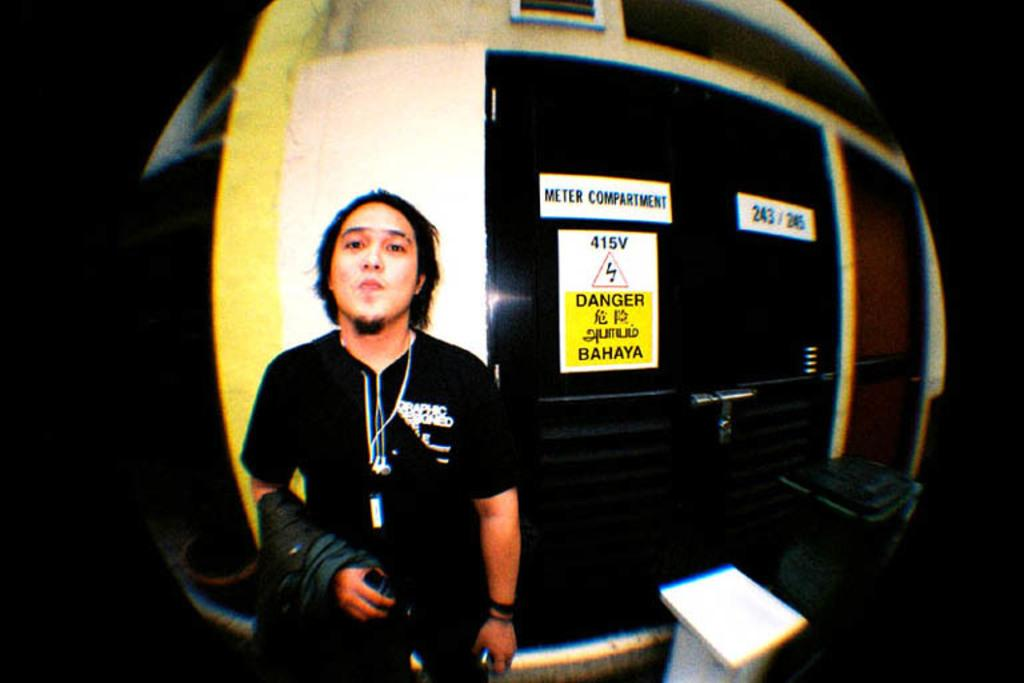Who is present in the image? There is a man in the image. What is the man holding in his hand? The man is holding a coat in his hand. What can be seen in the background of the image? There are plate plates visible in the background of the image. Is the man trying to escape from quicksand in the image? There is no quicksand present in the image, so the man is not trying to escape from it. 